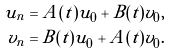Convert formula to latex. <formula><loc_0><loc_0><loc_500><loc_500>u _ { n } & = A ( t ) u _ { 0 } + B ( t ) v _ { 0 } , \\ v _ { n } & = B ( t ) u _ { 0 } + A ( t ) v _ { 0 } .</formula> 